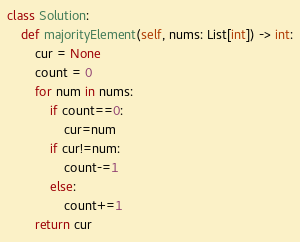<code> <loc_0><loc_0><loc_500><loc_500><_Python_>class Solution:
    def majorityElement(self, nums: List[int]) -> int:
        cur = None
        count = 0
        for num in nums:    
            if count==0:
                cur=num          
            if cur!=num:
                count-=1
            else:
                count+=1
        return cur</code> 